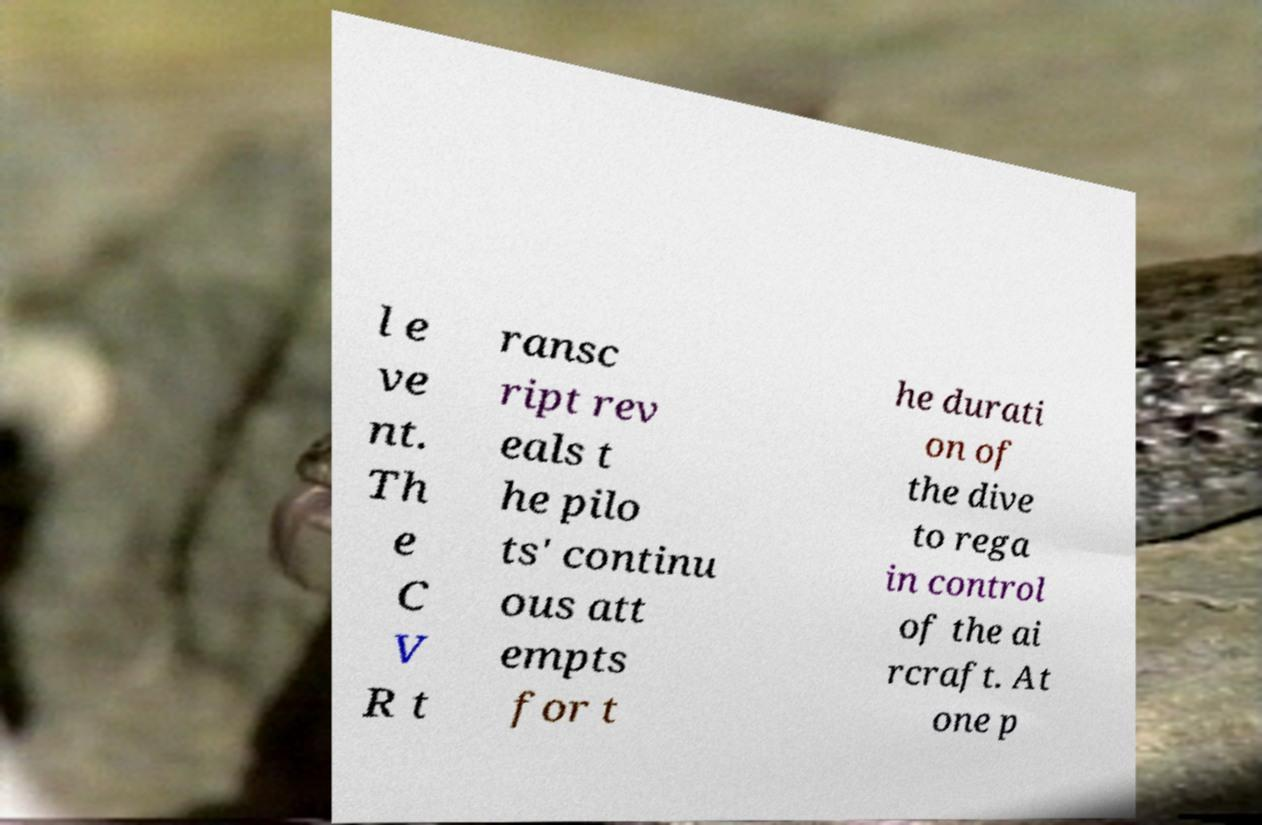I need the written content from this picture converted into text. Can you do that? l e ve nt. Th e C V R t ransc ript rev eals t he pilo ts' continu ous att empts for t he durati on of the dive to rega in control of the ai rcraft. At one p 